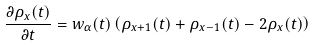<formula> <loc_0><loc_0><loc_500><loc_500>\frac { \partial \rho _ { x } ( t ) } { \partial t } = w _ { \alpha } ( t ) \left ( \rho _ { x + 1 } ( t ) + \rho _ { x - 1 } ( t ) - 2 \rho _ { x } ( t ) \right )</formula> 